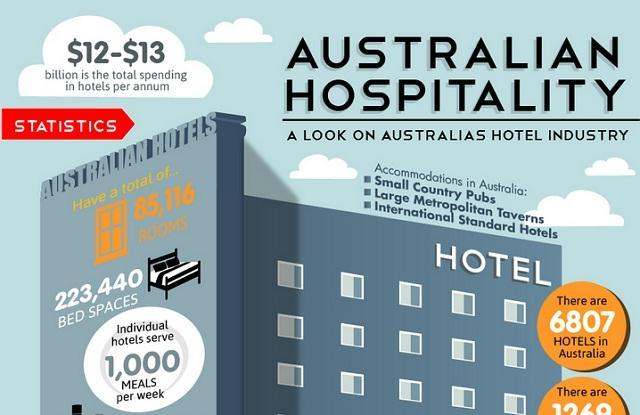How many meals does a hotel serve per week?
Answer the question with a short phrase. 1,000. What are the total number of rooms in Australian hotels? 85,116. 